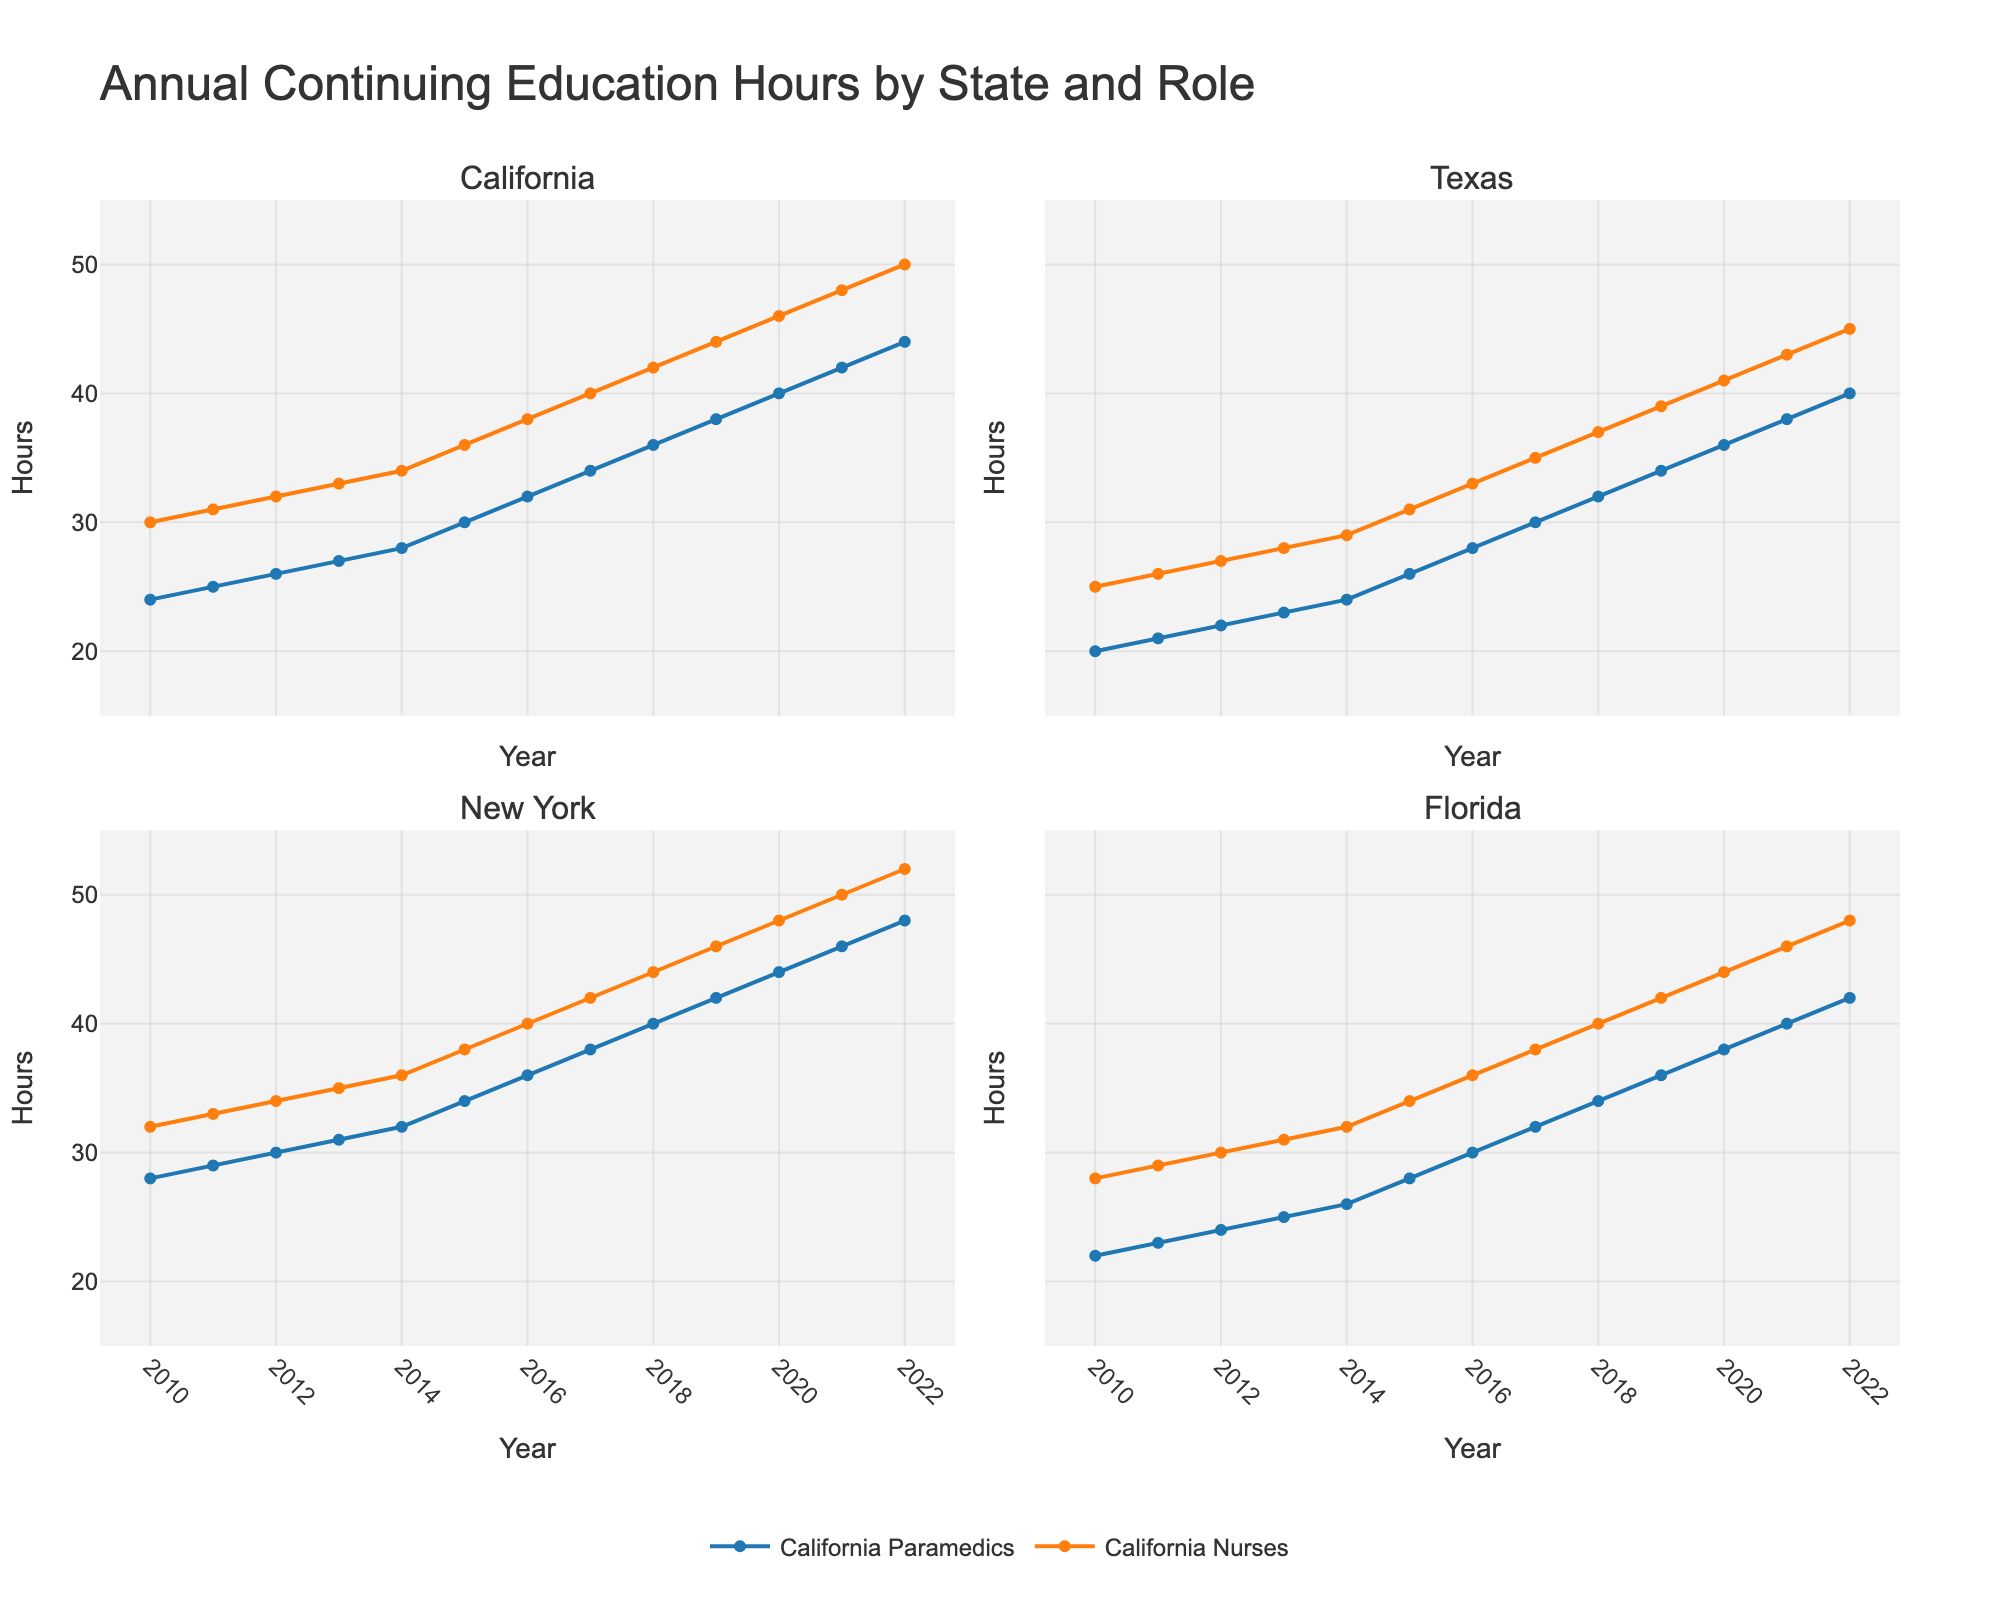What's the difference in continuing education hours for Texas Paramedics and Texas Nurses in 2022? Identify the 2022 data for Texas Paramedics (40 hours) and Texas Nurses (45 hours). Subtract the values (45 - 40).
Answer: 5 Which state had the highest annual continuing education hours for Paramedics in 2016? Compare the hours for all states' paramedics in 2016: California (32), Texas (28), New York (36), Florida (30). New York has the highest value.
Answer: New York What's the average continuing education hours for Florida Nurses from 2010 to 2015? Sum the education hours for Florida Nurses from 2010 (28), 2011 (29), 2012 (30), 2013 (31), 2014 (32), 2015 (34). The sum is 184. Divide by the number of years (184/6).
Answer: 30.67 By how much did the annual continuing education hours for California Paramedics increase from 2010 to 2022? Calculate the difference between 2010 (24 hours) and 2022 (44 hours) for California Paramedics (44 - 24).
Answer: 20 Which profession (paramedics or nurses) in New York showed a greater increase in continuing education hours from 2010 to 2022? Find the increase for New York Paramedics (48 - 28 = 20) and New York Nurses (52 - 32 = 20). Both have the same increase.
Answer: Both When did California Nurses first reach 40 hours of continuing education annually? Identify the year California Nurses reached 40 hours for the first time. Check the yearly figures and find it reached 40 in 2017.
Answer: 2017 What's the sum of annual continuing education hours for all paramedics in 2014? Add the hours for California (28), Texas (24), New York (32), Florida (26). The total sum is (28 + 24 + 32 + 26).
Answer: 110 Which year shows the highest difference between continuing education hours of California and Texas Nurses? Identify the differences for each year and find the maximum. The calculation is done by comparing differences annually, finding the largest in 2022 (50 - 45).
Answer: 2022 Which profession in Florida reached 40 hours of continuing education first, paramedics or nurses? Check the yearly data to see when Florida Paramedics and Nurses each reached 40 hours. Paramedics reached it in 2019, and Nurses in 2016.
Answer: Nurses What trend can be seen in the continuing education hours for Texas Paramedics from 2010 to 2022? Observe Texas Paramedics' annual hours from 2010 (20) to 2022 (40). There is a steady increase each year.
Answer: Steady Increase 